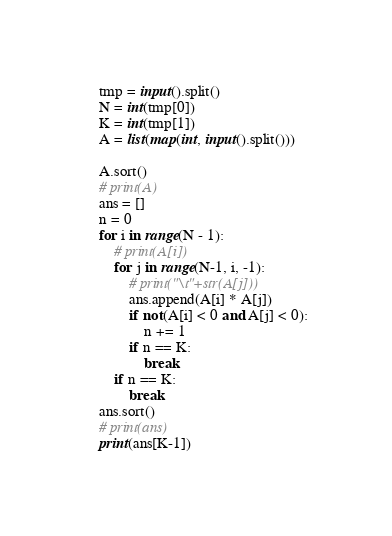<code> <loc_0><loc_0><loc_500><loc_500><_Python_>tmp = input().split()
N = int(tmp[0])
K = int(tmp[1])
A = list(map(int, input().split()))

A.sort()
# print(A)
ans = []
n = 0
for i in range(N - 1):
    # print(A[i])
    for j in range(N-1, i, -1):
        # print("\t"+str(A[j]))
        ans.append(A[i] * A[j])
        if not(A[i] < 0 and A[j] < 0):
            n += 1
        if n == K:
            break
    if n == K:
        break
ans.sort()
# print(ans)
print(ans[K-1])</code> 